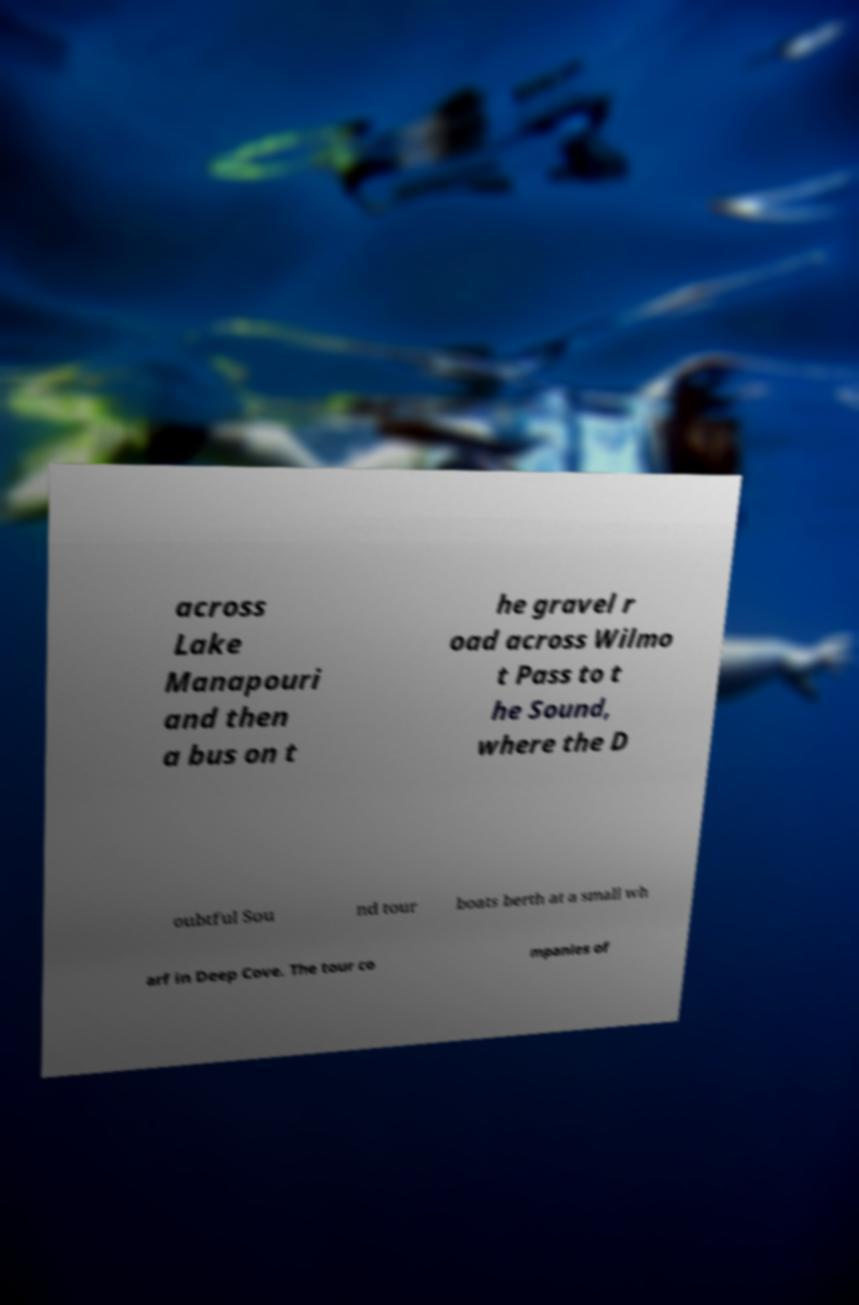I need the written content from this picture converted into text. Can you do that? across Lake Manapouri and then a bus on t he gravel r oad across Wilmo t Pass to t he Sound, where the D oubtful Sou nd tour boats berth at a small wh arf in Deep Cove. The tour co mpanies of 